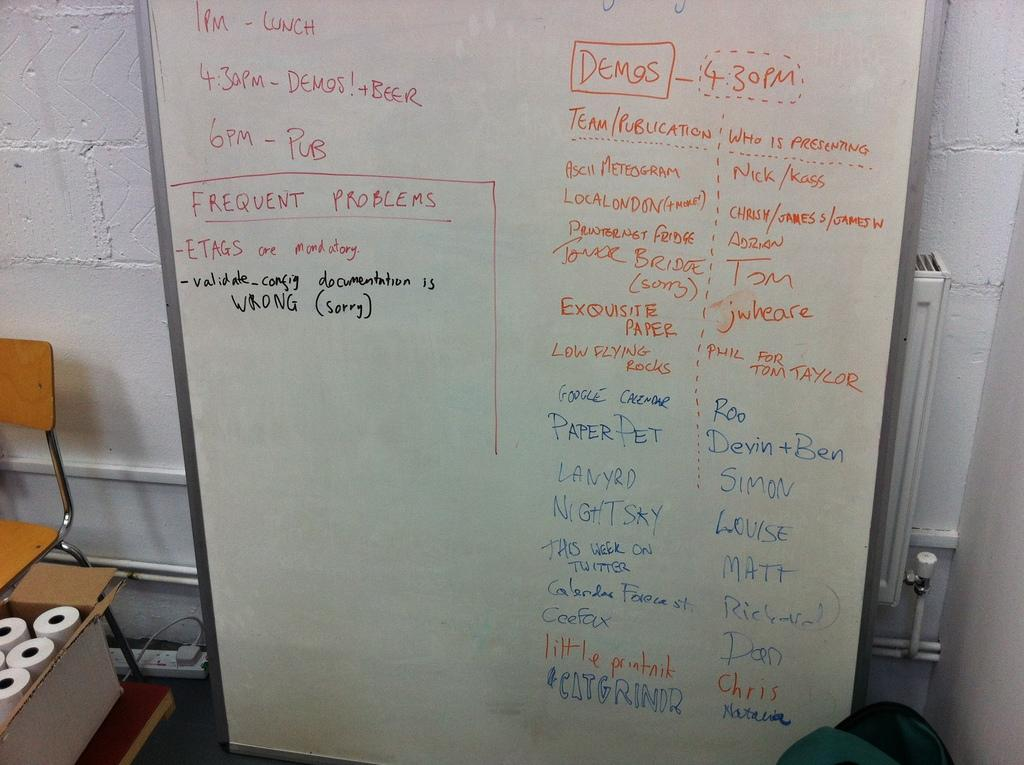<image>
Create a compact narrative representing the image presented. the word frequent is on the white board 